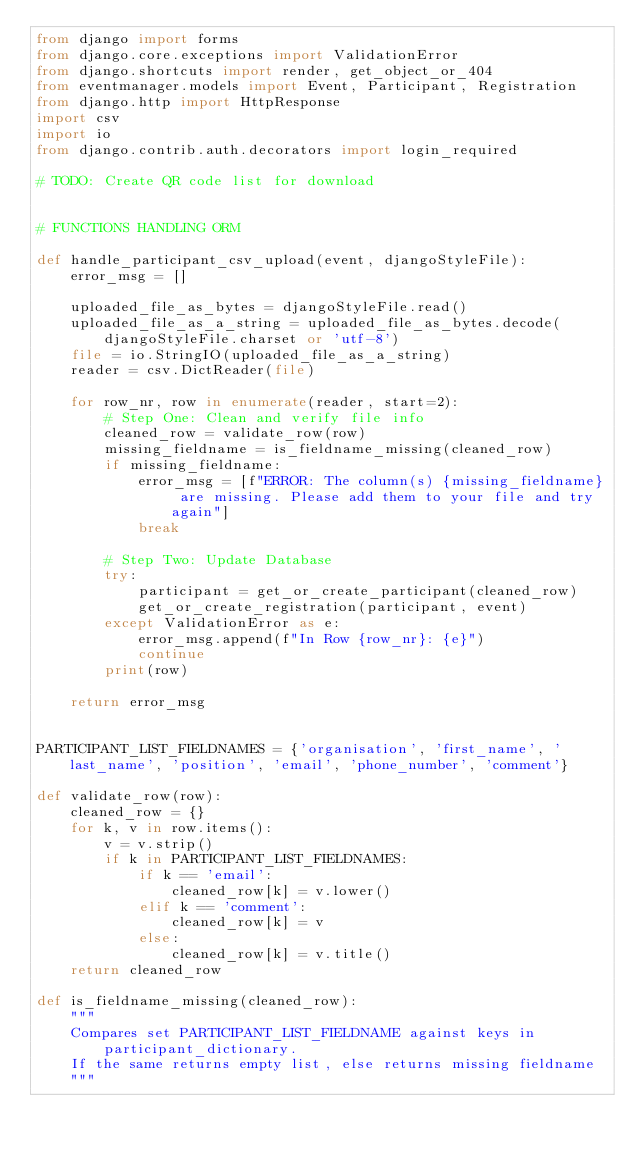<code> <loc_0><loc_0><loc_500><loc_500><_Python_>from django import forms
from django.core.exceptions import ValidationError
from django.shortcuts import render, get_object_or_404
from eventmanager.models import Event, Participant, Registration
from django.http import HttpResponse
import csv
import io
from django.contrib.auth.decorators import login_required

# TODO: Create QR code list for download 


# FUNCTIONS HANDLING ORM

def handle_participant_csv_upload(event, djangoStyleFile):
    error_msg = []

    uploaded_file_as_bytes = djangoStyleFile.read()
    uploaded_file_as_a_string = uploaded_file_as_bytes.decode(djangoStyleFile.charset or 'utf-8')
    file = io.StringIO(uploaded_file_as_a_string)
    reader = csv.DictReader(file)

    for row_nr, row in enumerate(reader, start=2):
        # Step One: Clean and verify file info
        cleaned_row = validate_row(row)
        missing_fieldname = is_fieldname_missing(cleaned_row)
        if missing_fieldname:
            error_msg = [f"ERROR: The column(s) {missing_fieldname} are missing. Please add them to your file and try again"]
            break
        
        # Step Two: Update Database
        try:
            participant = get_or_create_participant(cleaned_row)
            get_or_create_registration(participant, event)
        except ValidationError as e:
            error_msg.append(f"In Row {row_nr}: {e}")
            continue
        print(row)

    return error_msg


PARTICIPANT_LIST_FIELDNAMES = {'organisation', 'first_name', 'last_name', 'position', 'email', 'phone_number', 'comment'}

def validate_row(row):
    cleaned_row = {}
    for k, v in row.items():
        v = v.strip()
        if k in PARTICIPANT_LIST_FIELDNAMES:
            if k == 'email':
                cleaned_row[k] = v.lower()
            elif k == 'comment':
                cleaned_row[k] = v
            else:
                cleaned_row[k] = v.title()
    return cleaned_row

def is_fieldname_missing(cleaned_row):
    """
    Compares set PARTICIPANT_LIST_FIELDNAME against keys in participant_dictionary.
    If the same returns empty list, else returns missing fieldname
    """</code> 